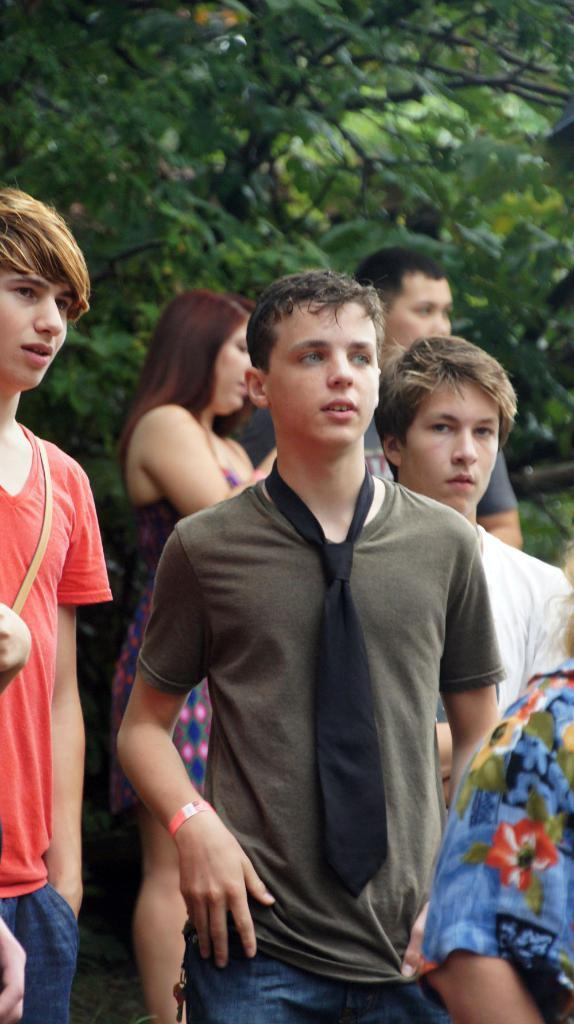What can be seen in the foreground of the picture? There are people in the foreground of the picture. What can be seen in the background of the picture? There is a woman and a man in the background of the picture, along with trees. What type of cream is being used by the fowl in the picture? There is no fowl or cream present in the image. What journey are the people in the picture taking? The facts provided do not give any information about a journey or the people's intentions, so we cannot determine if they are on a journey or not. 